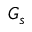<formula> <loc_0><loc_0><loc_500><loc_500>G _ { s }</formula> 